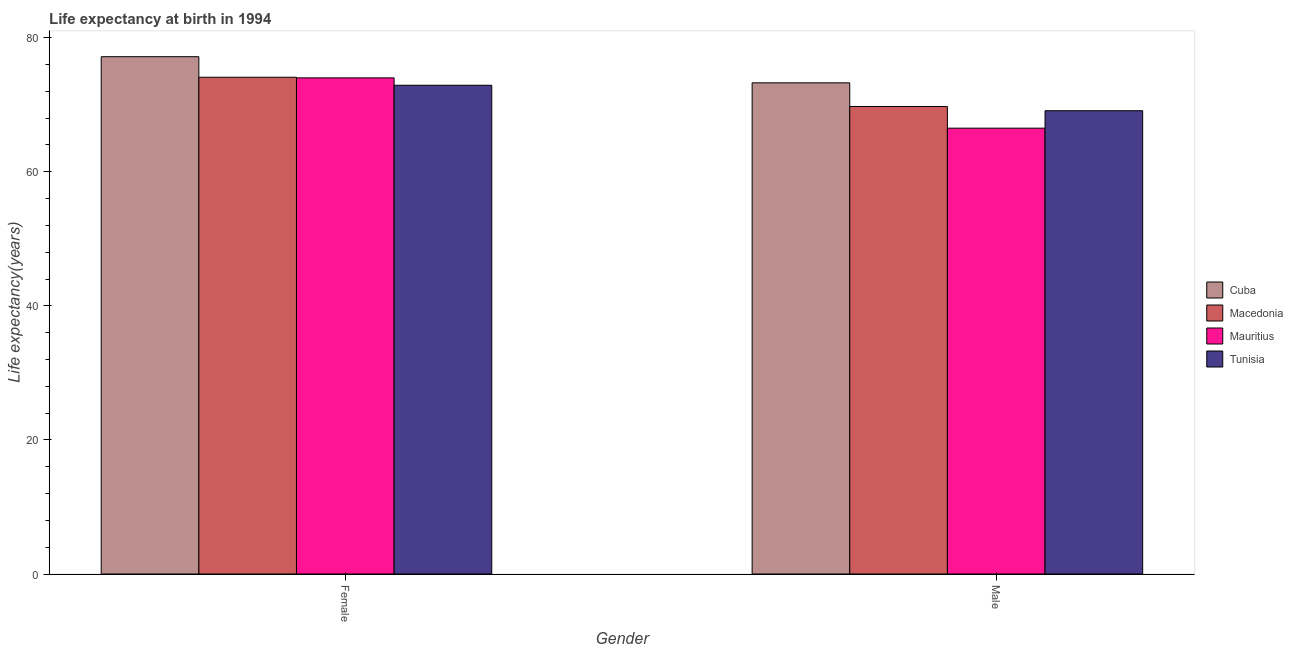How many different coloured bars are there?
Offer a terse response. 4. How many groups of bars are there?
Offer a terse response. 2. Are the number of bars per tick equal to the number of legend labels?
Provide a short and direct response. Yes. Are the number of bars on each tick of the X-axis equal?
Your answer should be compact. Yes. How many bars are there on the 2nd tick from the right?
Give a very brief answer. 4. What is the label of the 2nd group of bars from the left?
Provide a short and direct response. Male. What is the life expectancy(female) in Mauritius?
Give a very brief answer. 74. Across all countries, what is the maximum life expectancy(female)?
Make the answer very short. 77.16. Across all countries, what is the minimum life expectancy(male)?
Provide a succinct answer. 66.5. In which country was the life expectancy(male) maximum?
Your answer should be compact. Cuba. In which country was the life expectancy(female) minimum?
Provide a short and direct response. Tunisia. What is the total life expectancy(female) in the graph?
Provide a short and direct response. 298.15. What is the difference between the life expectancy(female) in Tunisia and that in Cuba?
Offer a very short reply. -4.26. What is the difference between the life expectancy(female) in Mauritius and the life expectancy(male) in Tunisia?
Make the answer very short. 4.9. What is the average life expectancy(female) per country?
Your answer should be very brief. 74.54. What is the difference between the life expectancy(female) and life expectancy(male) in Macedonia?
Your answer should be very brief. 4.36. What is the ratio of the life expectancy(male) in Mauritius to that in Cuba?
Offer a terse response. 0.91. What does the 4th bar from the left in Female represents?
Give a very brief answer. Tunisia. What does the 2nd bar from the right in Female represents?
Ensure brevity in your answer.  Mauritius. Are all the bars in the graph horizontal?
Provide a short and direct response. No. How many countries are there in the graph?
Your answer should be compact. 4. Where does the legend appear in the graph?
Provide a succinct answer. Center right. How are the legend labels stacked?
Offer a very short reply. Vertical. What is the title of the graph?
Provide a succinct answer. Life expectancy at birth in 1994. What is the label or title of the Y-axis?
Your answer should be very brief. Life expectancy(years). What is the Life expectancy(years) in Cuba in Female?
Your answer should be very brief. 77.16. What is the Life expectancy(years) of Macedonia in Female?
Keep it short and to the point. 74.09. What is the Life expectancy(years) in Tunisia in Female?
Your response must be concise. 72.9. What is the Life expectancy(years) of Cuba in Male?
Offer a very short reply. 73.26. What is the Life expectancy(years) in Macedonia in Male?
Your response must be concise. 69.73. What is the Life expectancy(years) of Mauritius in Male?
Ensure brevity in your answer.  66.5. What is the Life expectancy(years) of Tunisia in Male?
Provide a short and direct response. 69.1. Across all Gender, what is the maximum Life expectancy(years) in Cuba?
Give a very brief answer. 77.16. Across all Gender, what is the maximum Life expectancy(years) in Macedonia?
Ensure brevity in your answer.  74.09. Across all Gender, what is the maximum Life expectancy(years) in Tunisia?
Give a very brief answer. 72.9. Across all Gender, what is the minimum Life expectancy(years) in Cuba?
Offer a very short reply. 73.26. Across all Gender, what is the minimum Life expectancy(years) of Macedonia?
Ensure brevity in your answer.  69.73. Across all Gender, what is the minimum Life expectancy(years) in Mauritius?
Your answer should be very brief. 66.5. Across all Gender, what is the minimum Life expectancy(years) in Tunisia?
Give a very brief answer. 69.1. What is the total Life expectancy(years) in Cuba in the graph?
Provide a succinct answer. 150.42. What is the total Life expectancy(years) in Macedonia in the graph?
Your answer should be very brief. 143.83. What is the total Life expectancy(years) in Mauritius in the graph?
Make the answer very short. 140.5. What is the total Life expectancy(years) in Tunisia in the graph?
Provide a short and direct response. 142. What is the difference between the Life expectancy(years) in Cuba in Female and that in Male?
Offer a terse response. 3.9. What is the difference between the Life expectancy(years) of Macedonia in Female and that in Male?
Your response must be concise. 4.36. What is the difference between the Life expectancy(years) of Mauritius in Female and that in Male?
Offer a terse response. 7.5. What is the difference between the Life expectancy(years) in Tunisia in Female and that in Male?
Ensure brevity in your answer.  3.8. What is the difference between the Life expectancy(years) of Cuba in Female and the Life expectancy(years) of Macedonia in Male?
Your response must be concise. 7.43. What is the difference between the Life expectancy(years) of Cuba in Female and the Life expectancy(years) of Mauritius in Male?
Provide a short and direct response. 10.66. What is the difference between the Life expectancy(years) in Cuba in Female and the Life expectancy(years) in Tunisia in Male?
Your answer should be compact. 8.06. What is the difference between the Life expectancy(years) of Macedonia in Female and the Life expectancy(years) of Mauritius in Male?
Give a very brief answer. 7.59. What is the difference between the Life expectancy(years) of Macedonia in Female and the Life expectancy(years) of Tunisia in Male?
Make the answer very short. 4.99. What is the difference between the Life expectancy(years) of Mauritius in Female and the Life expectancy(years) of Tunisia in Male?
Provide a succinct answer. 4.9. What is the average Life expectancy(years) of Cuba per Gender?
Give a very brief answer. 75.21. What is the average Life expectancy(years) in Macedonia per Gender?
Give a very brief answer. 71.91. What is the average Life expectancy(years) in Mauritius per Gender?
Your answer should be compact. 70.25. What is the difference between the Life expectancy(years) in Cuba and Life expectancy(years) in Macedonia in Female?
Provide a short and direct response. 3.07. What is the difference between the Life expectancy(years) of Cuba and Life expectancy(years) of Mauritius in Female?
Ensure brevity in your answer.  3.16. What is the difference between the Life expectancy(years) in Cuba and Life expectancy(years) in Tunisia in Female?
Provide a succinct answer. 4.26. What is the difference between the Life expectancy(years) in Macedonia and Life expectancy(years) in Mauritius in Female?
Offer a terse response. 0.09. What is the difference between the Life expectancy(years) in Macedonia and Life expectancy(years) in Tunisia in Female?
Offer a terse response. 1.19. What is the difference between the Life expectancy(years) of Mauritius and Life expectancy(years) of Tunisia in Female?
Ensure brevity in your answer.  1.1. What is the difference between the Life expectancy(years) of Cuba and Life expectancy(years) of Macedonia in Male?
Your answer should be compact. 3.53. What is the difference between the Life expectancy(years) of Cuba and Life expectancy(years) of Mauritius in Male?
Your answer should be very brief. 6.76. What is the difference between the Life expectancy(years) of Cuba and Life expectancy(years) of Tunisia in Male?
Your answer should be very brief. 4.16. What is the difference between the Life expectancy(years) of Macedonia and Life expectancy(years) of Mauritius in Male?
Provide a short and direct response. 3.23. What is the difference between the Life expectancy(years) in Macedonia and Life expectancy(years) in Tunisia in Male?
Your response must be concise. 0.63. What is the ratio of the Life expectancy(years) in Cuba in Female to that in Male?
Give a very brief answer. 1.05. What is the ratio of the Life expectancy(years) in Macedonia in Female to that in Male?
Provide a short and direct response. 1.06. What is the ratio of the Life expectancy(years) of Mauritius in Female to that in Male?
Keep it short and to the point. 1.11. What is the ratio of the Life expectancy(years) of Tunisia in Female to that in Male?
Offer a terse response. 1.05. What is the difference between the highest and the second highest Life expectancy(years) of Cuba?
Your answer should be very brief. 3.9. What is the difference between the highest and the second highest Life expectancy(years) in Macedonia?
Give a very brief answer. 4.36. What is the difference between the highest and the second highest Life expectancy(years) in Mauritius?
Provide a short and direct response. 7.5. What is the difference between the highest and the second highest Life expectancy(years) of Tunisia?
Offer a terse response. 3.8. What is the difference between the highest and the lowest Life expectancy(years) in Cuba?
Give a very brief answer. 3.9. What is the difference between the highest and the lowest Life expectancy(years) in Macedonia?
Provide a short and direct response. 4.36. 